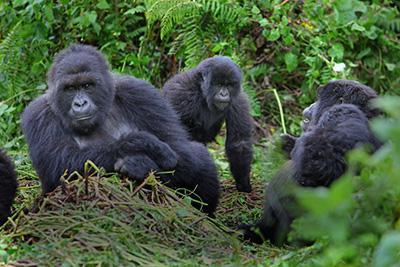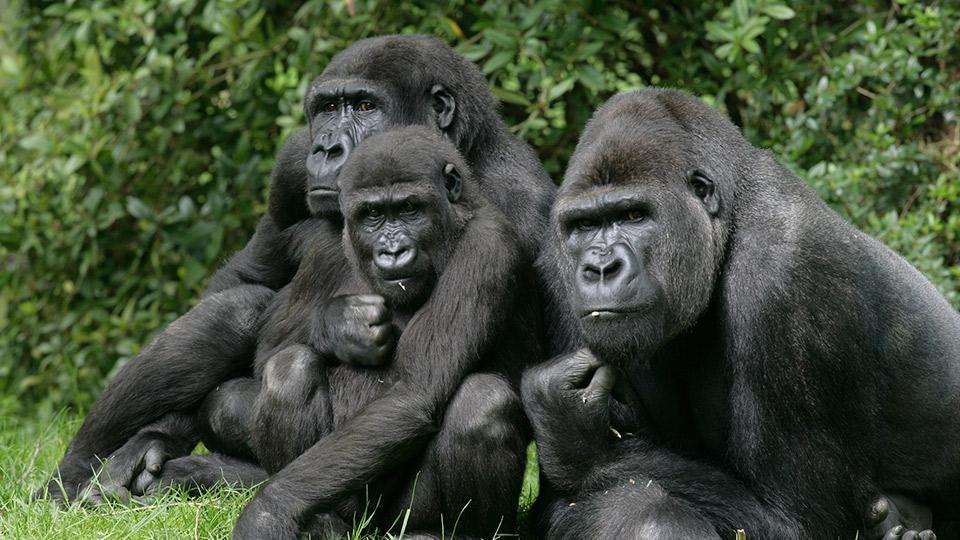The first image is the image on the left, the second image is the image on the right. Given the left and right images, does the statement "At least one of the gorillas has an open mouth." hold true? Answer yes or no. No. The first image is the image on the left, the second image is the image on the right. Given the left and right images, does the statement "A total of four gorillas are shown, and left and right images do not contain the same number of gorillas." hold true? Answer yes or no. No. 